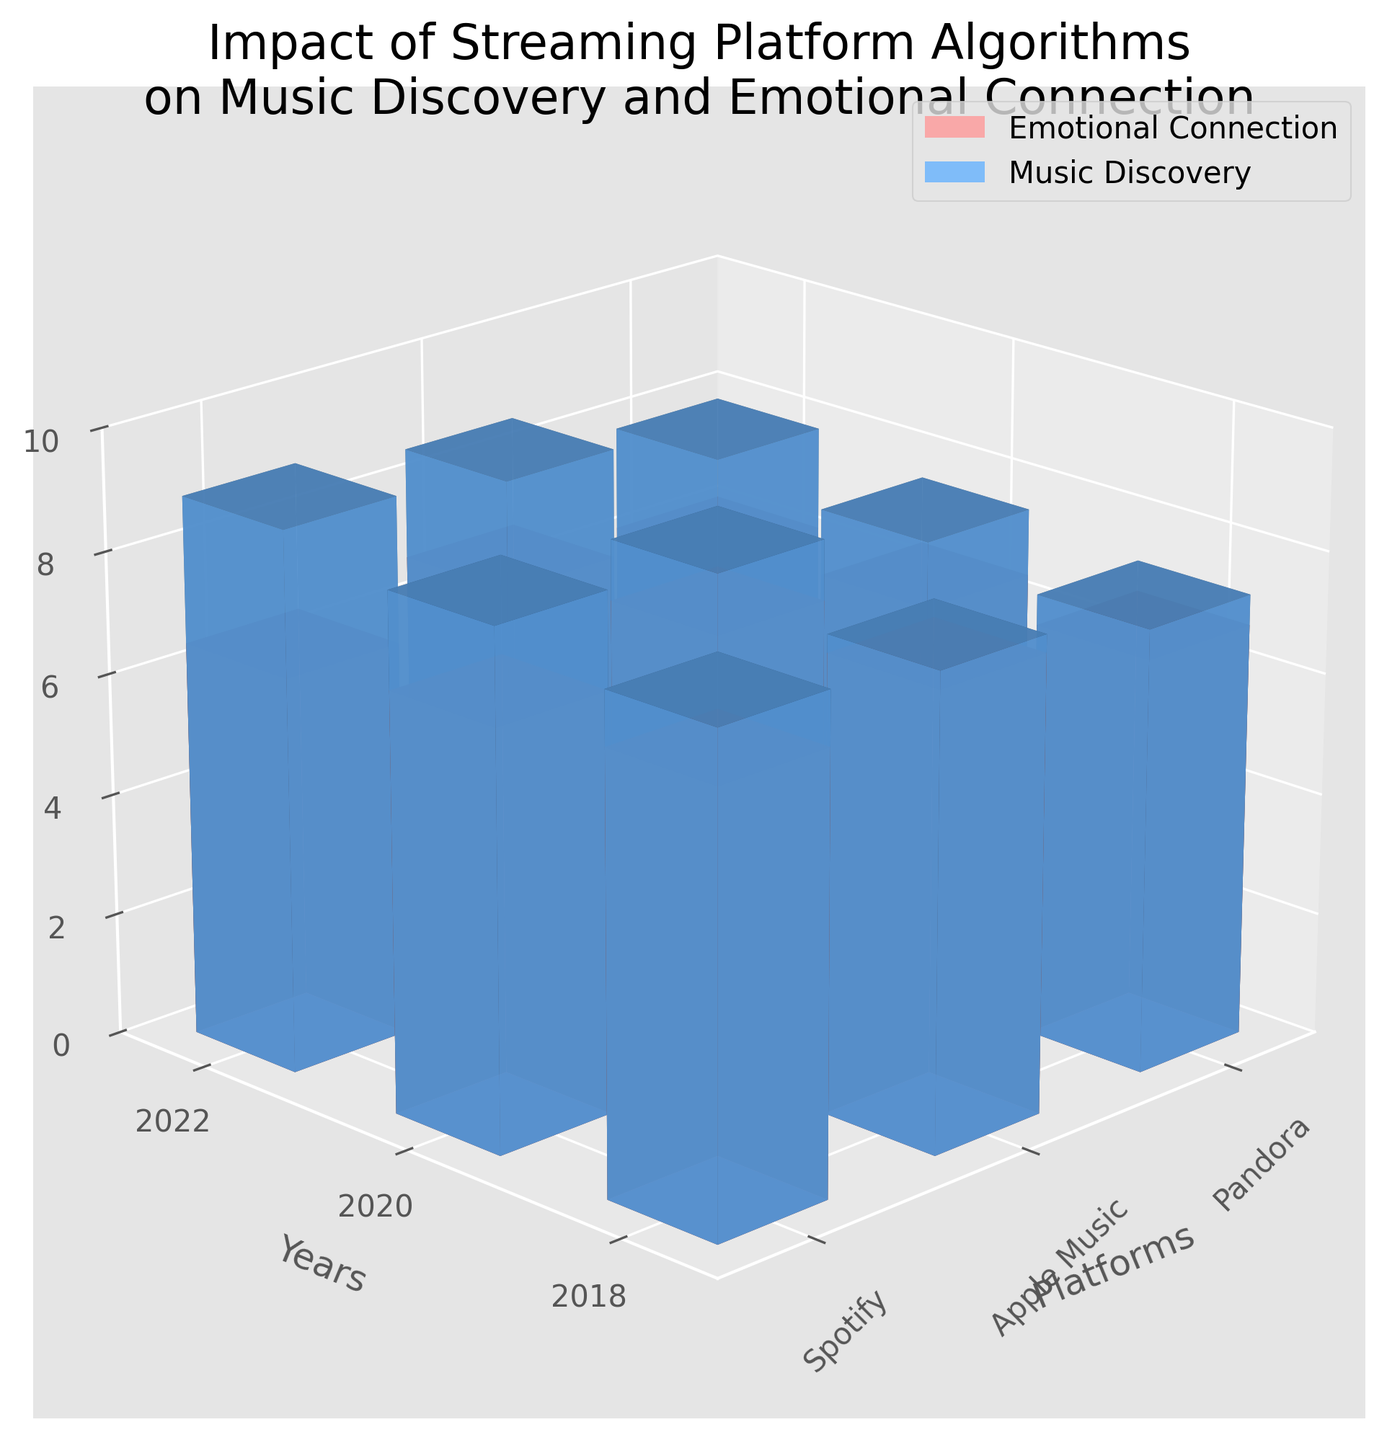What are the axes labels in the figure? The x-axis, y-axis, and z-axis labels provide the necessary context for interpreting the data. The x-axis is labeled 'Platforms', the y-axis is labeled 'Years', and the z-axis is labeled 'Score'.
Answer: Platforms, Years, Score Which platform had the highest music discovery score in 2018? To find this, look at the music discovery scores for 2018 across all platforms. The highest value is 8.1 for Spotify.
Answer: Spotify How did the emotional connection score for Pandora change from 2018 to 2022? Compare the emotional connection scores for Pandora in 2018 (6.8), 2020 (6.5), and 2022 (6.2). The score consistently decreased over this period.
Answer: Decreased What is the average music discovery score for Apple Music over all the years? Sum the music discovery scores for Apple Music over the years: 2018 (7.8), 2020 (8.2), and 2022 (8.6), then divide by the number of years. The average = (7.8 + 8.2 + 8.6) / 3 = 8.2.
Answer: 8.2 Which metric shows a higher variation in scores over time for Spotify: Emotional Connection or Music Discovery? Compare the range of scores for both metrics for Spotify over the years. Emotional Connection scores: 2018 (7.2), 2020 (6.9), 2022 (6.5) with a range of 7.2 - 6.5 = 0.7. Music Discovery scores: 2018 (8.1), 2020 (8.5), 2022 (8.9) with a range of 8.9 - 8.1 = 0.8. Music Discovery shows higher variation.
Answer: Music Discovery Which year had the lowest average emotional connection score across all platforms? Calculate the average emotional connection score for each year. For 2018: (7.2 + 7.5 + 6.8) / 3 = 7.17. For 2020: (6.9 + 7.2 + 6.5) / 3 = 6.87. For 2022: (6.5 + 6.8 + 6.2) / 3 = 6.5. The lowest score was in 2022.
Answer: 2022 Which platform showed the least improvement in music discovery scores from 2018 to 2022? Evaluate the change in music discovery scores for each platform from 2018 to 2022. Spotify: 8.1 to 8.9 (+0.8), Apple Music: 7.8 to 8.6 (+0.8), Pandora: 7.3 to 7.9 (+0.6). Pandora showed the least improvement.
Answer: Pandora 